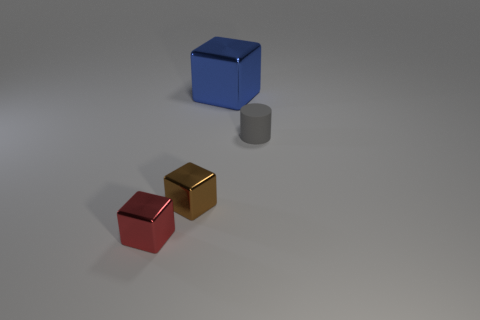What number of objects are tiny things that are right of the brown shiny block or shiny cubes?
Provide a succinct answer. 4. What is the tiny thing to the right of the small brown metallic object made of?
Your answer should be very brief. Rubber. What material is the blue object?
Your response must be concise. Metal. There is a small thing behind the small metal cube to the right of the tiny cube on the left side of the brown metallic cube; what is it made of?
Offer a very short reply. Rubber. Is there any other thing that has the same material as the gray object?
Make the answer very short. No. There is a red object; is it the same size as the cube that is behind the gray matte cylinder?
Make the answer very short. No. What number of things are either shiny blocks that are behind the cylinder or shiny things in front of the gray cylinder?
Provide a succinct answer. 3. There is a thing that is behind the rubber cylinder; what is its color?
Give a very brief answer. Blue. There is a small cube that is on the right side of the red metallic thing; are there any tiny shiny blocks that are in front of it?
Offer a very short reply. Yes. Are there fewer red metal things than cyan shiny objects?
Your response must be concise. No. 